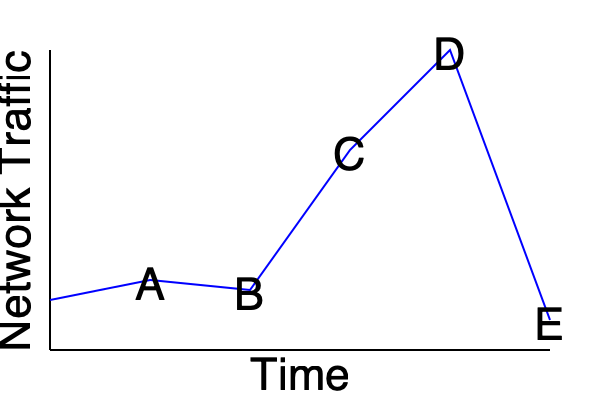Based on the network traffic pattern shown in the line graph, which point represents the most likely occurrence of a potential security incident that would trigger an automated response in your security orchestration playbook? To determine the most likely point of a potential security incident, we need to analyze the graph for anomalies in the network traffic pattern:

1. Point A: Shows a slight decrease in traffic, which is not unusual.
2. Point B: Indicates a small increase in traffic, still within normal range.
3. Point C: Demonstrates a significant spike in network traffic.
4. Point D: Represents the peak of the traffic spike.
5. Point E: Shows a sudden drop in traffic back to normal levels.

The most suspicious pattern is the sudden and dramatic increase in network traffic from point B to point C, peaking at point D. This rapid surge could indicate:

1. A Distributed Denial of Service (DDoS) attack
2. A large-scale data exfiltration attempt
3. The spread of malware or a worm within the network

Such anomalies would typically trigger automated responses in a security orchestration playbook, such as:

1. Isolating affected systems
2. Increasing logging and monitoring
3. Initiating traffic filtering or rate limiting
4. Alerting security personnel for further investigation

Therefore, point C, where the traffic starts to spike dramatically, is the most likely point where an automated response would be triggered in the security orchestration playbook.
Answer: Point C 